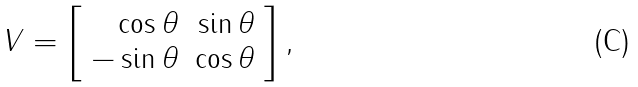<formula> <loc_0><loc_0><loc_500><loc_500>V = \left [ \begin{array} { r r } \cos \theta & \sin \theta \\ - \sin \theta & \cos \theta \end{array} \right ] ,</formula> 